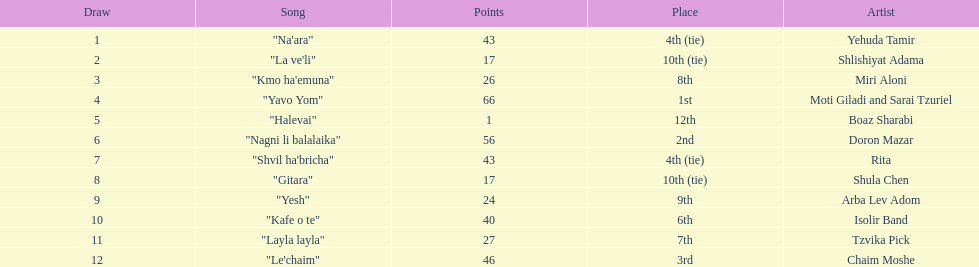Compare draws, which had the least amount of points? Boaz Sharabi. 